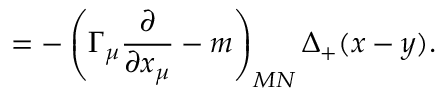<formula> <loc_0><loc_0><loc_500><loc_500>= - \left ( \Gamma _ { \mu } \frac { \partial } \partial x _ { \mu } } - m \right ) _ { M N } \Delta _ { + } ( x - y ) .</formula> 